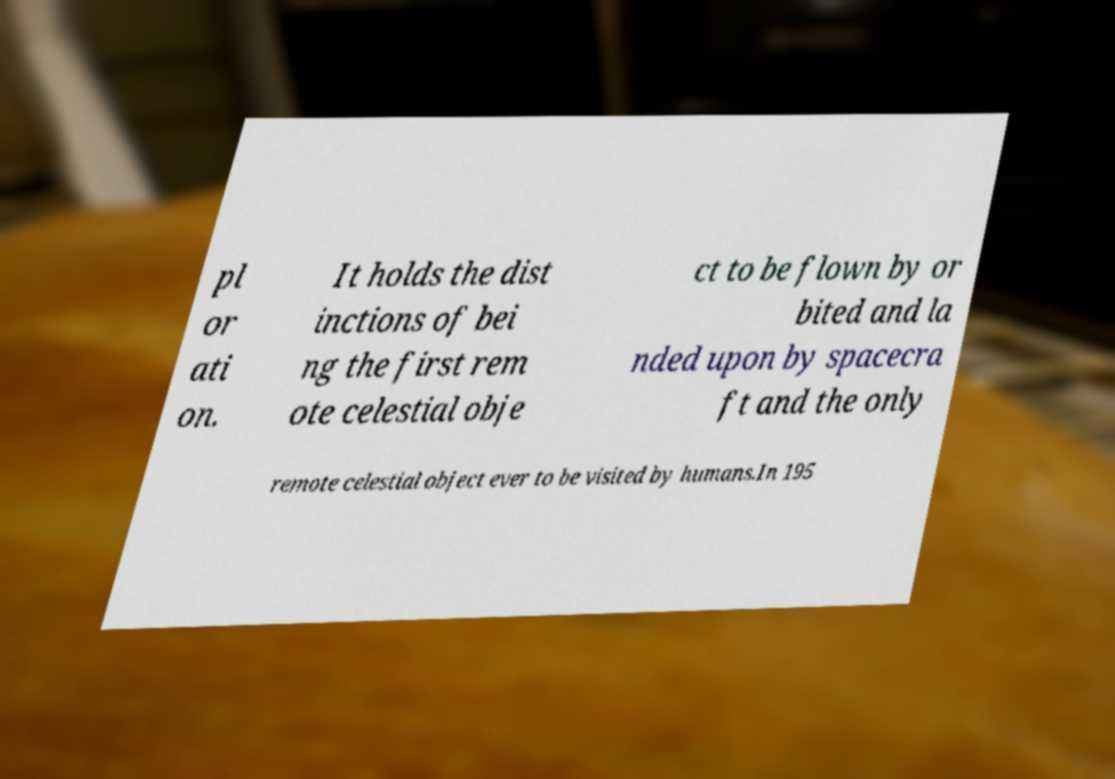What messages or text are displayed in this image? I need them in a readable, typed format. pl or ati on. It holds the dist inctions of bei ng the first rem ote celestial obje ct to be flown by or bited and la nded upon by spacecra ft and the only remote celestial object ever to be visited by humans.In 195 